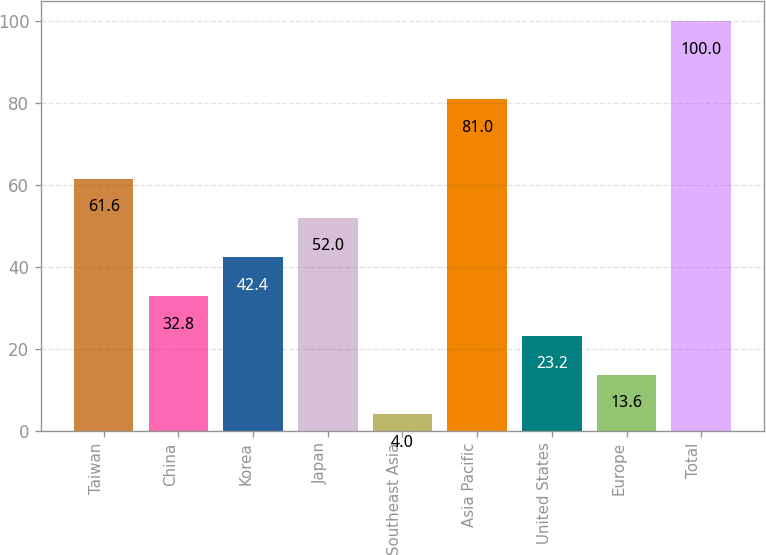Convert chart to OTSL. <chart><loc_0><loc_0><loc_500><loc_500><bar_chart><fcel>Taiwan<fcel>China<fcel>Korea<fcel>Japan<fcel>Southeast Asia<fcel>Asia Pacific<fcel>United States<fcel>Europe<fcel>Total<nl><fcel>61.6<fcel>32.8<fcel>42.4<fcel>52<fcel>4<fcel>81<fcel>23.2<fcel>13.6<fcel>100<nl></chart> 